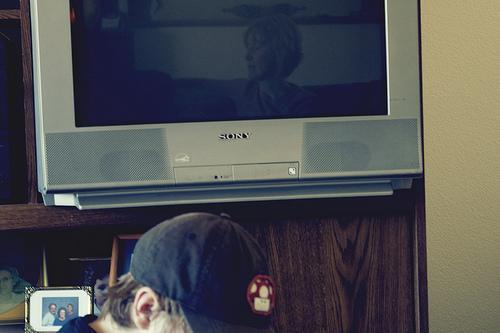How many people are wearing hats?
Give a very brief answer. 1. 